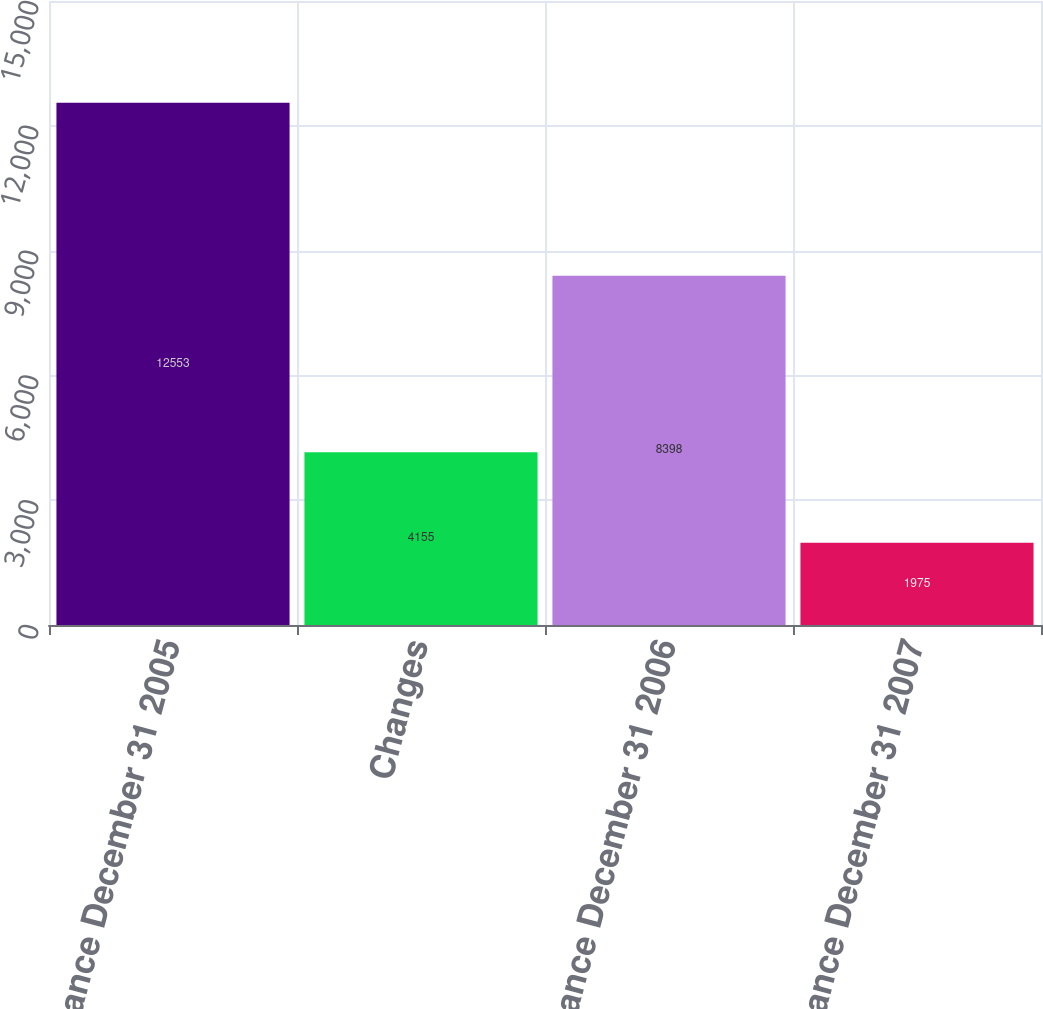Convert chart. <chart><loc_0><loc_0><loc_500><loc_500><bar_chart><fcel>Balance December 31 2005<fcel>Changes<fcel>Balance December 31 2006<fcel>Balance December 31 2007<nl><fcel>12553<fcel>4155<fcel>8398<fcel>1975<nl></chart> 